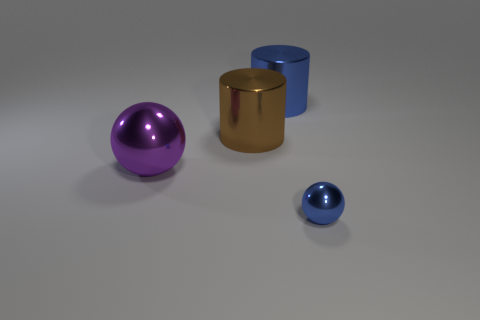What number of things are in front of the small blue metallic ball?
Give a very brief answer. 0. What number of things are either large brown cylinders or blue metal balls?
Provide a succinct answer. 2. What is the shape of the large metal object that is behind the big purple metallic sphere and to the left of the large blue thing?
Offer a terse response. Cylinder. What number of large rubber things are there?
Provide a succinct answer. 0. There is another small object that is the same material as the brown thing; what is its color?
Your answer should be very brief. Blue. Is the number of tiny blue spheres greater than the number of cyan metal spheres?
Ensure brevity in your answer.  Yes. There is a metallic object that is both behind the tiny object and in front of the large brown metal cylinder; what is its size?
Provide a short and direct response. Large. There is a large thing that is the same color as the small sphere; what is its material?
Provide a short and direct response. Metal. Are there an equal number of blue spheres that are in front of the purple metallic object and big blue metallic cylinders?
Make the answer very short. Yes. Do the brown object and the blue cylinder have the same size?
Give a very brief answer. Yes. 